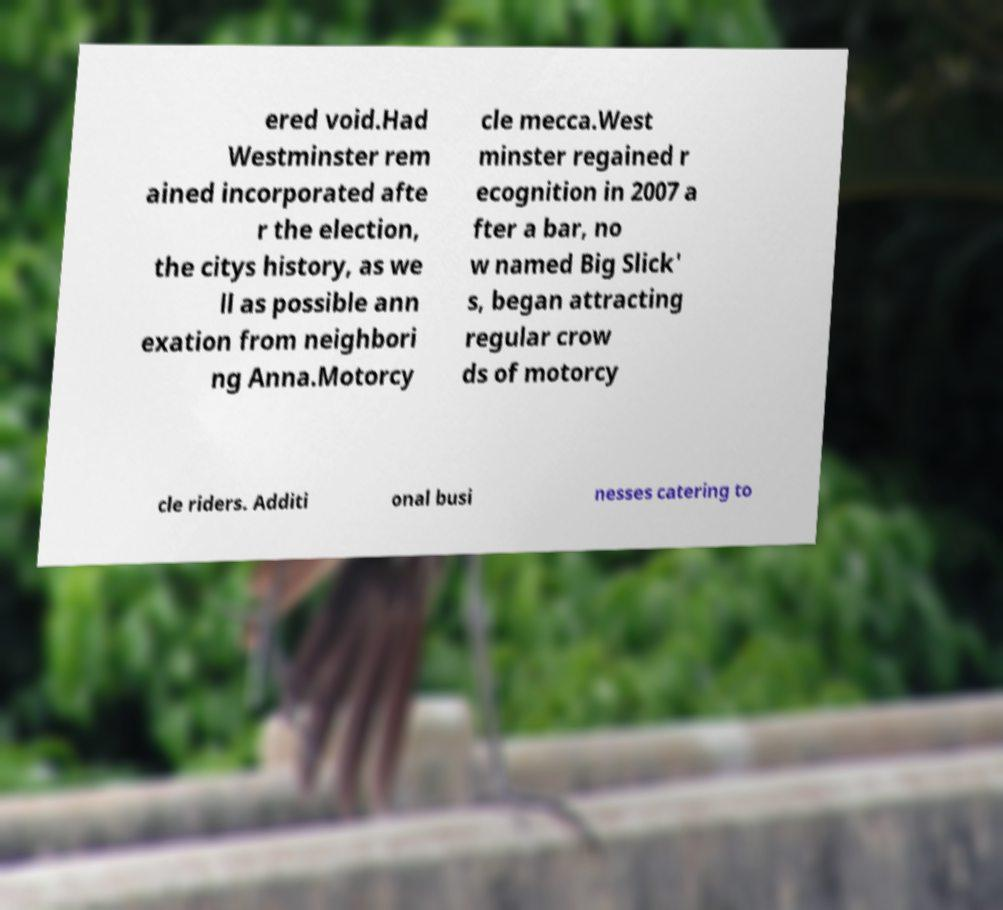Can you read and provide the text displayed in the image?This photo seems to have some interesting text. Can you extract and type it out for me? ered void.Had Westminster rem ained incorporated afte r the election, the citys history, as we ll as possible ann exation from neighbori ng Anna.Motorcy cle mecca.West minster regained r ecognition in 2007 a fter a bar, no w named Big Slick' s, began attracting regular crow ds of motorcy cle riders. Additi onal busi nesses catering to 